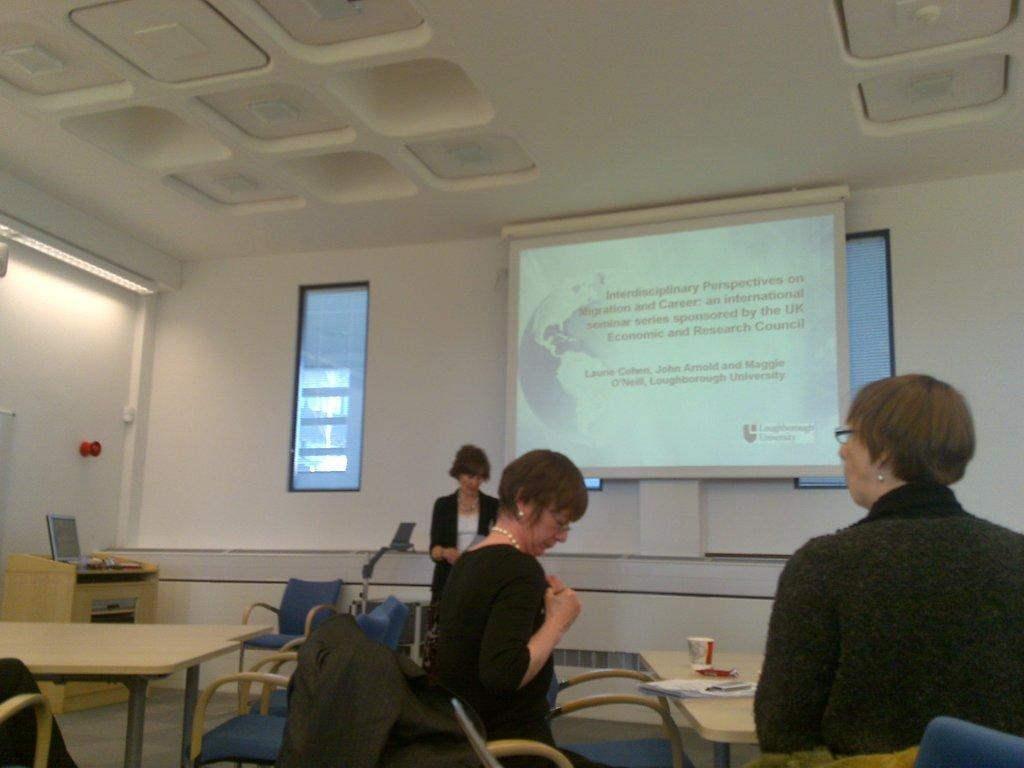How many people are in the image? There is a group of people in the image, but the exact number is not specified. What are the people doing in the image? The people are standing near a table and a chair. What can be seen in the background of the image? There is a window and a screen in the background of the image. What type of berry is being sold at the market in the image? There is no market or berry present in the image. How many books are visible on the table in the image? There is no mention of books in the image; the table is near the people, but no specific items are described on it. 